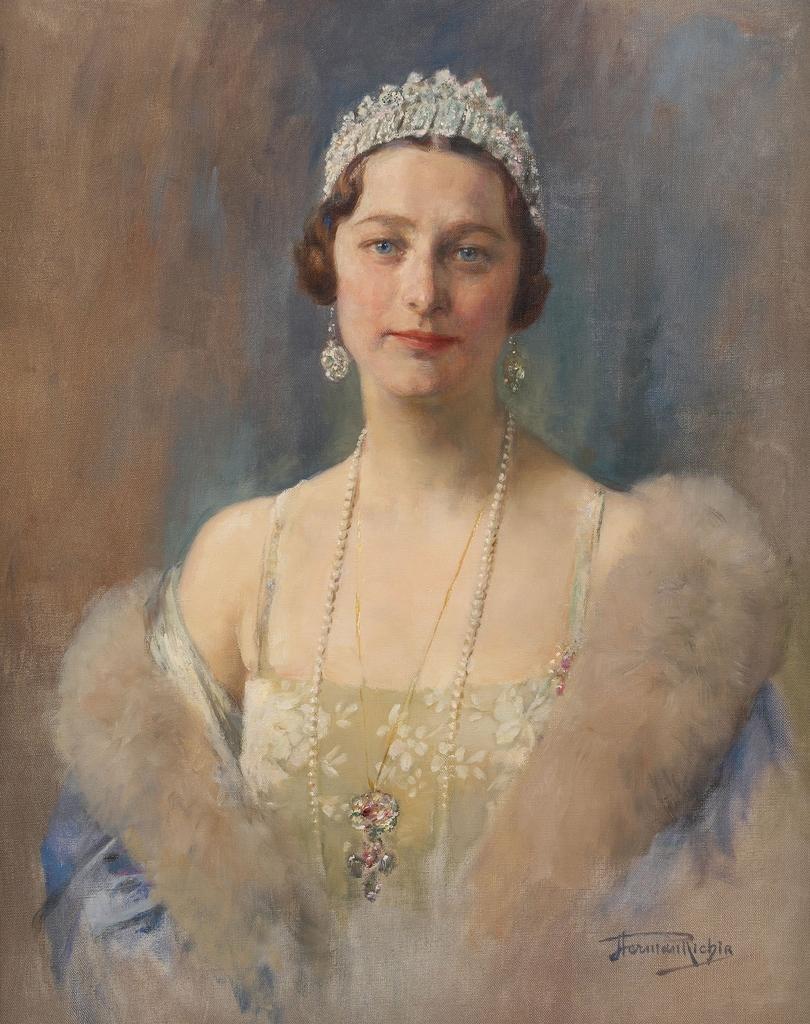Could you give a brief overview of what you see in this image? In this picture we can see the painting of a woman with the crown. On the painting it is written something. 